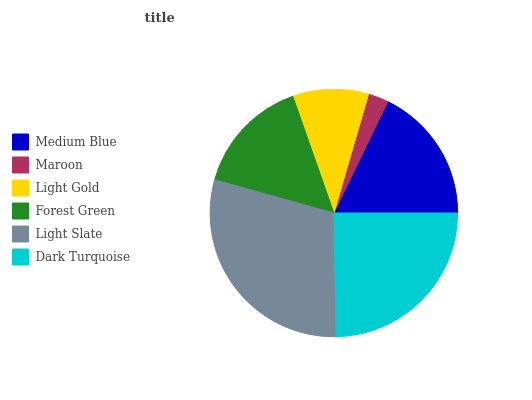Is Maroon the minimum?
Answer yes or no. Yes. Is Light Slate the maximum?
Answer yes or no. Yes. Is Light Gold the minimum?
Answer yes or no. No. Is Light Gold the maximum?
Answer yes or no. No. Is Light Gold greater than Maroon?
Answer yes or no. Yes. Is Maroon less than Light Gold?
Answer yes or no. Yes. Is Maroon greater than Light Gold?
Answer yes or no. No. Is Light Gold less than Maroon?
Answer yes or no. No. Is Medium Blue the high median?
Answer yes or no. Yes. Is Forest Green the low median?
Answer yes or no. Yes. Is Forest Green the high median?
Answer yes or no. No. Is Light Slate the low median?
Answer yes or no. No. 